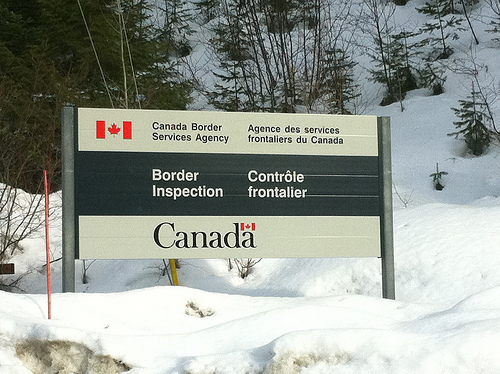<image>
Is there a flag in front of the snow? Yes. The flag is positioned in front of the snow, appearing closer to the camera viewpoint. 